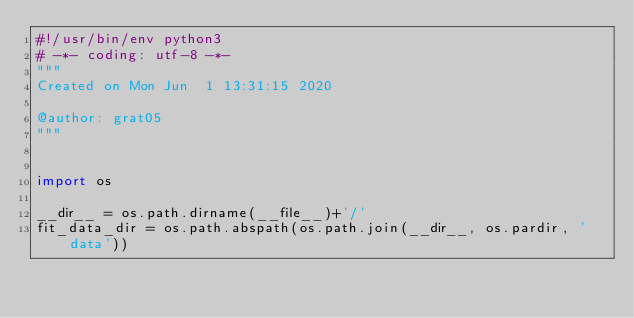Convert code to text. <code><loc_0><loc_0><loc_500><loc_500><_Python_>#!/usr/bin/env python3
# -*- coding: utf-8 -*-
"""
Created on Mon Jun  1 13:31:15 2020

@author: grat05
"""


import os

__dir__ = os.path.dirname(__file__)+'/'
fit_data_dir = os.path.abspath(os.path.join(__dir__, os.pardir, 'data'))</code> 